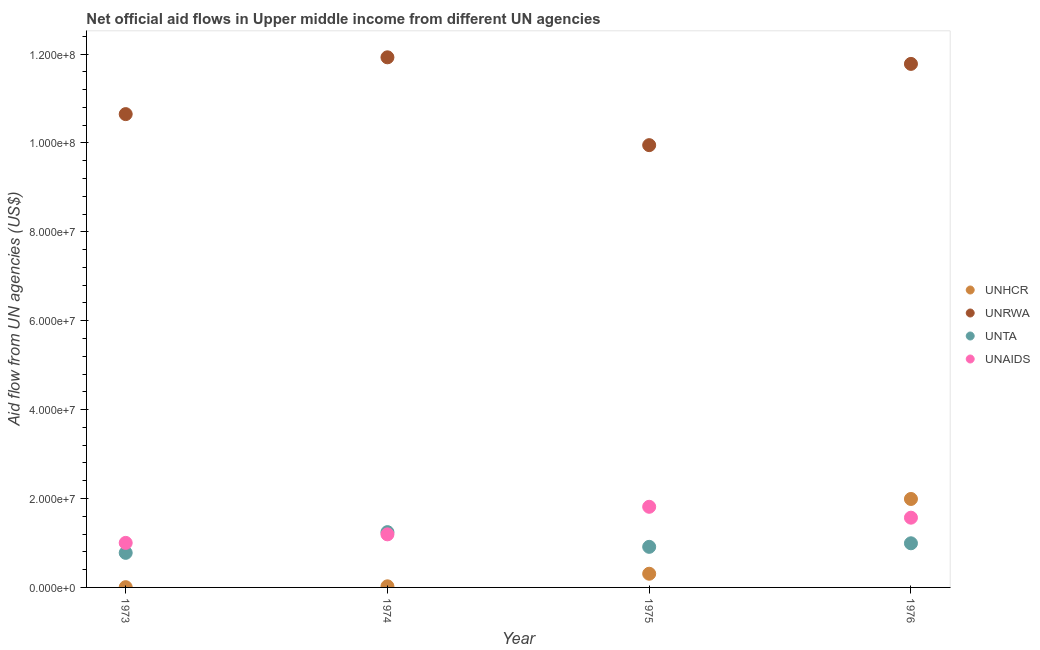Is the number of dotlines equal to the number of legend labels?
Provide a short and direct response. Yes. What is the amount of aid given by unaids in 1973?
Provide a short and direct response. 1.00e+07. Across all years, what is the maximum amount of aid given by unta?
Offer a very short reply. 1.24e+07. Across all years, what is the minimum amount of aid given by unaids?
Provide a succinct answer. 1.00e+07. In which year was the amount of aid given by unrwa maximum?
Ensure brevity in your answer.  1974. What is the total amount of aid given by unaids in the graph?
Your answer should be very brief. 5.58e+07. What is the difference between the amount of aid given by unta in 1975 and that in 1976?
Ensure brevity in your answer.  -8.00e+05. What is the difference between the amount of aid given by unrwa in 1976 and the amount of aid given by unta in 1973?
Offer a terse response. 1.10e+08. What is the average amount of aid given by unhcr per year?
Ensure brevity in your answer.  5.82e+06. In the year 1974, what is the difference between the amount of aid given by unrwa and amount of aid given by unaids?
Provide a short and direct response. 1.07e+08. What is the ratio of the amount of aid given by unaids in 1975 to that in 1976?
Ensure brevity in your answer.  1.16. Is the difference between the amount of aid given by unhcr in 1973 and 1974 greater than the difference between the amount of aid given by unaids in 1973 and 1974?
Offer a very short reply. Yes. What is the difference between the highest and the second highest amount of aid given by unrwa?
Provide a succinct answer. 1.48e+06. What is the difference between the highest and the lowest amount of aid given by unta?
Offer a terse response. 4.66e+06. In how many years, is the amount of aid given by unaids greater than the average amount of aid given by unaids taken over all years?
Your response must be concise. 2. Is the sum of the amount of aid given by unrwa in 1974 and 1976 greater than the maximum amount of aid given by unaids across all years?
Your response must be concise. Yes. Is it the case that in every year, the sum of the amount of aid given by unhcr and amount of aid given by unrwa is greater than the amount of aid given by unta?
Your response must be concise. Yes. Is the amount of aid given by unaids strictly greater than the amount of aid given by unhcr over the years?
Offer a terse response. No. Is the amount of aid given by unrwa strictly less than the amount of aid given by unta over the years?
Make the answer very short. No. How many years are there in the graph?
Provide a short and direct response. 4. Are the values on the major ticks of Y-axis written in scientific E-notation?
Make the answer very short. Yes. Does the graph contain any zero values?
Provide a succinct answer. No. Does the graph contain grids?
Provide a succinct answer. No. Where does the legend appear in the graph?
Offer a very short reply. Center right. How are the legend labels stacked?
Keep it short and to the point. Vertical. What is the title of the graph?
Provide a succinct answer. Net official aid flows in Upper middle income from different UN agencies. What is the label or title of the X-axis?
Keep it short and to the point. Year. What is the label or title of the Y-axis?
Your answer should be very brief. Aid flow from UN agencies (US$). What is the Aid flow from UN agencies (US$) of UNHCR in 1973?
Make the answer very short. 6.00e+04. What is the Aid flow from UN agencies (US$) in UNRWA in 1973?
Your answer should be very brief. 1.06e+08. What is the Aid flow from UN agencies (US$) in UNTA in 1973?
Your answer should be compact. 7.78e+06. What is the Aid flow from UN agencies (US$) of UNAIDS in 1973?
Provide a short and direct response. 1.00e+07. What is the Aid flow from UN agencies (US$) in UNHCR in 1974?
Give a very brief answer. 2.50e+05. What is the Aid flow from UN agencies (US$) of UNRWA in 1974?
Provide a succinct answer. 1.19e+08. What is the Aid flow from UN agencies (US$) in UNTA in 1974?
Give a very brief answer. 1.24e+07. What is the Aid flow from UN agencies (US$) of UNAIDS in 1974?
Provide a short and direct response. 1.19e+07. What is the Aid flow from UN agencies (US$) of UNHCR in 1975?
Make the answer very short. 3.08e+06. What is the Aid flow from UN agencies (US$) in UNRWA in 1975?
Provide a succinct answer. 9.95e+07. What is the Aid flow from UN agencies (US$) of UNTA in 1975?
Offer a terse response. 9.13e+06. What is the Aid flow from UN agencies (US$) of UNAIDS in 1975?
Ensure brevity in your answer.  1.81e+07. What is the Aid flow from UN agencies (US$) of UNHCR in 1976?
Your response must be concise. 1.99e+07. What is the Aid flow from UN agencies (US$) in UNRWA in 1976?
Your response must be concise. 1.18e+08. What is the Aid flow from UN agencies (US$) in UNTA in 1976?
Make the answer very short. 9.93e+06. What is the Aid flow from UN agencies (US$) in UNAIDS in 1976?
Make the answer very short. 1.57e+07. Across all years, what is the maximum Aid flow from UN agencies (US$) in UNHCR?
Provide a succinct answer. 1.99e+07. Across all years, what is the maximum Aid flow from UN agencies (US$) of UNRWA?
Keep it short and to the point. 1.19e+08. Across all years, what is the maximum Aid flow from UN agencies (US$) of UNTA?
Give a very brief answer. 1.24e+07. Across all years, what is the maximum Aid flow from UN agencies (US$) in UNAIDS?
Your answer should be very brief. 1.81e+07. Across all years, what is the minimum Aid flow from UN agencies (US$) in UNHCR?
Your answer should be compact. 6.00e+04. Across all years, what is the minimum Aid flow from UN agencies (US$) of UNRWA?
Ensure brevity in your answer.  9.95e+07. Across all years, what is the minimum Aid flow from UN agencies (US$) in UNTA?
Offer a very short reply. 7.78e+06. Across all years, what is the minimum Aid flow from UN agencies (US$) of UNAIDS?
Your response must be concise. 1.00e+07. What is the total Aid flow from UN agencies (US$) in UNHCR in the graph?
Offer a terse response. 2.33e+07. What is the total Aid flow from UN agencies (US$) in UNRWA in the graph?
Offer a very short reply. 4.43e+08. What is the total Aid flow from UN agencies (US$) of UNTA in the graph?
Offer a very short reply. 3.93e+07. What is the total Aid flow from UN agencies (US$) in UNAIDS in the graph?
Keep it short and to the point. 5.58e+07. What is the difference between the Aid flow from UN agencies (US$) of UNHCR in 1973 and that in 1974?
Keep it short and to the point. -1.90e+05. What is the difference between the Aid flow from UN agencies (US$) of UNRWA in 1973 and that in 1974?
Keep it short and to the point. -1.28e+07. What is the difference between the Aid flow from UN agencies (US$) in UNTA in 1973 and that in 1974?
Your answer should be compact. -4.66e+06. What is the difference between the Aid flow from UN agencies (US$) of UNAIDS in 1973 and that in 1974?
Your answer should be very brief. -1.92e+06. What is the difference between the Aid flow from UN agencies (US$) in UNHCR in 1973 and that in 1975?
Your response must be concise. -3.02e+06. What is the difference between the Aid flow from UN agencies (US$) of UNRWA in 1973 and that in 1975?
Offer a terse response. 6.98e+06. What is the difference between the Aid flow from UN agencies (US$) of UNTA in 1973 and that in 1975?
Your response must be concise. -1.35e+06. What is the difference between the Aid flow from UN agencies (US$) of UNAIDS in 1973 and that in 1975?
Offer a terse response. -8.12e+06. What is the difference between the Aid flow from UN agencies (US$) of UNHCR in 1973 and that in 1976?
Give a very brief answer. -1.98e+07. What is the difference between the Aid flow from UN agencies (US$) in UNRWA in 1973 and that in 1976?
Your answer should be very brief. -1.13e+07. What is the difference between the Aid flow from UN agencies (US$) in UNTA in 1973 and that in 1976?
Ensure brevity in your answer.  -2.15e+06. What is the difference between the Aid flow from UN agencies (US$) in UNAIDS in 1973 and that in 1976?
Keep it short and to the point. -5.67e+06. What is the difference between the Aid flow from UN agencies (US$) in UNHCR in 1974 and that in 1975?
Offer a very short reply. -2.83e+06. What is the difference between the Aid flow from UN agencies (US$) in UNRWA in 1974 and that in 1975?
Make the answer very short. 1.98e+07. What is the difference between the Aid flow from UN agencies (US$) of UNTA in 1974 and that in 1975?
Give a very brief answer. 3.31e+06. What is the difference between the Aid flow from UN agencies (US$) of UNAIDS in 1974 and that in 1975?
Offer a very short reply. -6.20e+06. What is the difference between the Aid flow from UN agencies (US$) of UNHCR in 1974 and that in 1976?
Your answer should be very brief. -1.96e+07. What is the difference between the Aid flow from UN agencies (US$) of UNRWA in 1974 and that in 1976?
Give a very brief answer. 1.48e+06. What is the difference between the Aid flow from UN agencies (US$) in UNTA in 1974 and that in 1976?
Give a very brief answer. 2.51e+06. What is the difference between the Aid flow from UN agencies (US$) in UNAIDS in 1974 and that in 1976?
Offer a very short reply. -3.75e+06. What is the difference between the Aid flow from UN agencies (US$) of UNHCR in 1975 and that in 1976?
Give a very brief answer. -1.68e+07. What is the difference between the Aid flow from UN agencies (US$) in UNRWA in 1975 and that in 1976?
Your response must be concise. -1.83e+07. What is the difference between the Aid flow from UN agencies (US$) of UNTA in 1975 and that in 1976?
Your answer should be compact. -8.00e+05. What is the difference between the Aid flow from UN agencies (US$) in UNAIDS in 1975 and that in 1976?
Provide a succinct answer. 2.45e+06. What is the difference between the Aid flow from UN agencies (US$) in UNHCR in 1973 and the Aid flow from UN agencies (US$) in UNRWA in 1974?
Your answer should be very brief. -1.19e+08. What is the difference between the Aid flow from UN agencies (US$) of UNHCR in 1973 and the Aid flow from UN agencies (US$) of UNTA in 1974?
Ensure brevity in your answer.  -1.24e+07. What is the difference between the Aid flow from UN agencies (US$) of UNHCR in 1973 and the Aid flow from UN agencies (US$) of UNAIDS in 1974?
Give a very brief answer. -1.19e+07. What is the difference between the Aid flow from UN agencies (US$) of UNRWA in 1973 and the Aid flow from UN agencies (US$) of UNTA in 1974?
Keep it short and to the point. 9.40e+07. What is the difference between the Aid flow from UN agencies (US$) in UNRWA in 1973 and the Aid flow from UN agencies (US$) in UNAIDS in 1974?
Your response must be concise. 9.45e+07. What is the difference between the Aid flow from UN agencies (US$) in UNTA in 1973 and the Aid flow from UN agencies (US$) in UNAIDS in 1974?
Your answer should be compact. -4.16e+06. What is the difference between the Aid flow from UN agencies (US$) of UNHCR in 1973 and the Aid flow from UN agencies (US$) of UNRWA in 1975?
Give a very brief answer. -9.94e+07. What is the difference between the Aid flow from UN agencies (US$) of UNHCR in 1973 and the Aid flow from UN agencies (US$) of UNTA in 1975?
Provide a short and direct response. -9.07e+06. What is the difference between the Aid flow from UN agencies (US$) of UNHCR in 1973 and the Aid flow from UN agencies (US$) of UNAIDS in 1975?
Make the answer very short. -1.81e+07. What is the difference between the Aid flow from UN agencies (US$) in UNRWA in 1973 and the Aid flow from UN agencies (US$) in UNTA in 1975?
Provide a succinct answer. 9.74e+07. What is the difference between the Aid flow from UN agencies (US$) of UNRWA in 1973 and the Aid flow from UN agencies (US$) of UNAIDS in 1975?
Your answer should be compact. 8.83e+07. What is the difference between the Aid flow from UN agencies (US$) in UNTA in 1973 and the Aid flow from UN agencies (US$) in UNAIDS in 1975?
Offer a terse response. -1.04e+07. What is the difference between the Aid flow from UN agencies (US$) in UNHCR in 1973 and the Aid flow from UN agencies (US$) in UNRWA in 1976?
Your answer should be very brief. -1.18e+08. What is the difference between the Aid flow from UN agencies (US$) of UNHCR in 1973 and the Aid flow from UN agencies (US$) of UNTA in 1976?
Your answer should be very brief. -9.87e+06. What is the difference between the Aid flow from UN agencies (US$) of UNHCR in 1973 and the Aid flow from UN agencies (US$) of UNAIDS in 1976?
Provide a short and direct response. -1.56e+07. What is the difference between the Aid flow from UN agencies (US$) in UNRWA in 1973 and the Aid flow from UN agencies (US$) in UNTA in 1976?
Your answer should be compact. 9.66e+07. What is the difference between the Aid flow from UN agencies (US$) in UNRWA in 1973 and the Aid flow from UN agencies (US$) in UNAIDS in 1976?
Provide a succinct answer. 9.08e+07. What is the difference between the Aid flow from UN agencies (US$) in UNTA in 1973 and the Aid flow from UN agencies (US$) in UNAIDS in 1976?
Keep it short and to the point. -7.91e+06. What is the difference between the Aid flow from UN agencies (US$) in UNHCR in 1974 and the Aid flow from UN agencies (US$) in UNRWA in 1975?
Make the answer very short. -9.92e+07. What is the difference between the Aid flow from UN agencies (US$) in UNHCR in 1974 and the Aid flow from UN agencies (US$) in UNTA in 1975?
Your answer should be compact. -8.88e+06. What is the difference between the Aid flow from UN agencies (US$) in UNHCR in 1974 and the Aid flow from UN agencies (US$) in UNAIDS in 1975?
Ensure brevity in your answer.  -1.79e+07. What is the difference between the Aid flow from UN agencies (US$) of UNRWA in 1974 and the Aid flow from UN agencies (US$) of UNTA in 1975?
Your answer should be very brief. 1.10e+08. What is the difference between the Aid flow from UN agencies (US$) of UNRWA in 1974 and the Aid flow from UN agencies (US$) of UNAIDS in 1975?
Offer a terse response. 1.01e+08. What is the difference between the Aid flow from UN agencies (US$) in UNTA in 1974 and the Aid flow from UN agencies (US$) in UNAIDS in 1975?
Provide a short and direct response. -5.70e+06. What is the difference between the Aid flow from UN agencies (US$) in UNHCR in 1974 and the Aid flow from UN agencies (US$) in UNRWA in 1976?
Your response must be concise. -1.18e+08. What is the difference between the Aid flow from UN agencies (US$) in UNHCR in 1974 and the Aid flow from UN agencies (US$) in UNTA in 1976?
Offer a very short reply. -9.68e+06. What is the difference between the Aid flow from UN agencies (US$) of UNHCR in 1974 and the Aid flow from UN agencies (US$) of UNAIDS in 1976?
Offer a terse response. -1.54e+07. What is the difference between the Aid flow from UN agencies (US$) in UNRWA in 1974 and the Aid flow from UN agencies (US$) in UNTA in 1976?
Keep it short and to the point. 1.09e+08. What is the difference between the Aid flow from UN agencies (US$) of UNRWA in 1974 and the Aid flow from UN agencies (US$) of UNAIDS in 1976?
Make the answer very short. 1.04e+08. What is the difference between the Aid flow from UN agencies (US$) of UNTA in 1974 and the Aid flow from UN agencies (US$) of UNAIDS in 1976?
Make the answer very short. -3.25e+06. What is the difference between the Aid flow from UN agencies (US$) of UNHCR in 1975 and the Aid flow from UN agencies (US$) of UNRWA in 1976?
Your answer should be very brief. -1.15e+08. What is the difference between the Aid flow from UN agencies (US$) of UNHCR in 1975 and the Aid flow from UN agencies (US$) of UNTA in 1976?
Provide a short and direct response. -6.85e+06. What is the difference between the Aid flow from UN agencies (US$) of UNHCR in 1975 and the Aid flow from UN agencies (US$) of UNAIDS in 1976?
Your response must be concise. -1.26e+07. What is the difference between the Aid flow from UN agencies (US$) in UNRWA in 1975 and the Aid flow from UN agencies (US$) in UNTA in 1976?
Provide a succinct answer. 8.96e+07. What is the difference between the Aid flow from UN agencies (US$) of UNRWA in 1975 and the Aid flow from UN agencies (US$) of UNAIDS in 1976?
Give a very brief answer. 8.38e+07. What is the difference between the Aid flow from UN agencies (US$) in UNTA in 1975 and the Aid flow from UN agencies (US$) in UNAIDS in 1976?
Make the answer very short. -6.56e+06. What is the average Aid flow from UN agencies (US$) of UNHCR per year?
Provide a succinct answer. 5.82e+06. What is the average Aid flow from UN agencies (US$) in UNRWA per year?
Your answer should be very brief. 1.11e+08. What is the average Aid flow from UN agencies (US$) of UNTA per year?
Ensure brevity in your answer.  9.82e+06. What is the average Aid flow from UN agencies (US$) in UNAIDS per year?
Provide a short and direct response. 1.39e+07. In the year 1973, what is the difference between the Aid flow from UN agencies (US$) in UNHCR and Aid flow from UN agencies (US$) in UNRWA?
Make the answer very short. -1.06e+08. In the year 1973, what is the difference between the Aid flow from UN agencies (US$) of UNHCR and Aid flow from UN agencies (US$) of UNTA?
Your answer should be compact. -7.72e+06. In the year 1973, what is the difference between the Aid flow from UN agencies (US$) of UNHCR and Aid flow from UN agencies (US$) of UNAIDS?
Your answer should be compact. -9.96e+06. In the year 1973, what is the difference between the Aid flow from UN agencies (US$) in UNRWA and Aid flow from UN agencies (US$) in UNTA?
Keep it short and to the point. 9.87e+07. In the year 1973, what is the difference between the Aid flow from UN agencies (US$) of UNRWA and Aid flow from UN agencies (US$) of UNAIDS?
Your answer should be very brief. 9.65e+07. In the year 1973, what is the difference between the Aid flow from UN agencies (US$) of UNTA and Aid flow from UN agencies (US$) of UNAIDS?
Your answer should be very brief. -2.24e+06. In the year 1974, what is the difference between the Aid flow from UN agencies (US$) of UNHCR and Aid flow from UN agencies (US$) of UNRWA?
Ensure brevity in your answer.  -1.19e+08. In the year 1974, what is the difference between the Aid flow from UN agencies (US$) in UNHCR and Aid flow from UN agencies (US$) in UNTA?
Provide a succinct answer. -1.22e+07. In the year 1974, what is the difference between the Aid flow from UN agencies (US$) of UNHCR and Aid flow from UN agencies (US$) of UNAIDS?
Your answer should be compact. -1.17e+07. In the year 1974, what is the difference between the Aid flow from UN agencies (US$) of UNRWA and Aid flow from UN agencies (US$) of UNTA?
Offer a very short reply. 1.07e+08. In the year 1974, what is the difference between the Aid flow from UN agencies (US$) of UNRWA and Aid flow from UN agencies (US$) of UNAIDS?
Ensure brevity in your answer.  1.07e+08. In the year 1974, what is the difference between the Aid flow from UN agencies (US$) in UNTA and Aid flow from UN agencies (US$) in UNAIDS?
Provide a succinct answer. 5.00e+05. In the year 1975, what is the difference between the Aid flow from UN agencies (US$) of UNHCR and Aid flow from UN agencies (US$) of UNRWA?
Your answer should be very brief. -9.64e+07. In the year 1975, what is the difference between the Aid flow from UN agencies (US$) in UNHCR and Aid flow from UN agencies (US$) in UNTA?
Give a very brief answer. -6.05e+06. In the year 1975, what is the difference between the Aid flow from UN agencies (US$) in UNHCR and Aid flow from UN agencies (US$) in UNAIDS?
Make the answer very short. -1.51e+07. In the year 1975, what is the difference between the Aid flow from UN agencies (US$) of UNRWA and Aid flow from UN agencies (US$) of UNTA?
Make the answer very short. 9.04e+07. In the year 1975, what is the difference between the Aid flow from UN agencies (US$) in UNRWA and Aid flow from UN agencies (US$) in UNAIDS?
Your answer should be compact. 8.14e+07. In the year 1975, what is the difference between the Aid flow from UN agencies (US$) of UNTA and Aid flow from UN agencies (US$) of UNAIDS?
Keep it short and to the point. -9.01e+06. In the year 1976, what is the difference between the Aid flow from UN agencies (US$) of UNHCR and Aid flow from UN agencies (US$) of UNRWA?
Give a very brief answer. -9.79e+07. In the year 1976, what is the difference between the Aid flow from UN agencies (US$) of UNHCR and Aid flow from UN agencies (US$) of UNTA?
Make the answer very short. 9.97e+06. In the year 1976, what is the difference between the Aid flow from UN agencies (US$) of UNHCR and Aid flow from UN agencies (US$) of UNAIDS?
Your answer should be very brief. 4.21e+06. In the year 1976, what is the difference between the Aid flow from UN agencies (US$) of UNRWA and Aid flow from UN agencies (US$) of UNTA?
Your response must be concise. 1.08e+08. In the year 1976, what is the difference between the Aid flow from UN agencies (US$) of UNRWA and Aid flow from UN agencies (US$) of UNAIDS?
Your response must be concise. 1.02e+08. In the year 1976, what is the difference between the Aid flow from UN agencies (US$) of UNTA and Aid flow from UN agencies (US$) of UNAIDS?
Make the answer very short. -5.76e+06. What is the ratio of the Aid flow from UN agencies (US$) of UNHCR in 1973 to that in 1974?
Ensure brevity in your answer.  0.24. What is the ratio of the Aid flow from UN agencies (US$) in UNRWA in 1973 to that in 1974?
Make the answer very short. 0.89. What is the ratio of the Aid flow from UN agencies (US$) in UNTA in 1973 to that in 1974?
Your answer should be very brief. 0.63. What is the ratio of the Aid flow from UN agencies (US$) of UNAIDS in 1973 to that in 1974?
Offer a terse response. 0.84. What is the ratio of the Aid flow from UN agencies (US$) in UNHCR in 1973 to that in 1975?
Provide a succinct answer. 0.02. What is the ratio of the Aid flow from UN agencies (US$) of UNRWA in 1973 to that in 1975?
Your answer should be compact. 1.07. What is the ratio of the Aid flow from UN agencies (US$) of UNTA in 1973 to that in 1975?
Your answer should be compact. 0.85. What is the ratio of the Aid flow from UN agencies (US$) in UNAIDS in 1973 to that in 1975?
Provide a succinct answer. 0.55. What is the ratio of the Aid flow from UN agencies (US$) in UNHCR in 1973 to that in 1976?
Ensure brevity in your answer.  0. What is the ratio of the Aid flow from UN agencies (US$) in UNRWA in 1973 to that in 1976?
Make the answer very short. 0.9. What is the ratio of the Aid flow from UN agencies (US$) in UNTA in 1973 to that in 1976?
Offer a terse response. 0.78. What is the ratio of the Aid flow from UN agencies (US$) in UNAIDS in 1973 to that in 1976?
Keep it short and to the point. 0.64. What is the ratio of the Aid flow from UN agencies (US$) of UNHCR in 1974 to that in 1975?
Your answer should be compact. 0.08. What is the ratio of the Aid flow from UN agencies (US$) in UNRWA in 1974 to that in 1975?
Your answer should be compact. 1.2. What is the ratio of the Aid flow from UN agencies (US$) in UNTA in 1974 to that in 1975?
Provide a short and direct response. 1.36. What is the ratio of the Aid flow from UN agencies (US$) in UNAIDS in 1974 to that in 1975?
Give a very brief answer. 0.66. What is the ratio of the Aid flow from UN agencies (US$) in UNHCR in 1974 to that in 1976?
Provide a succinct answer. 0.01. What is the ratio of the Aid flow from UN agencies (US$) in UNRWA in 1974 to that in 1976?
Offer a very short reply. 1.01. What is the ratio of the Aid flow from UN agencies (US$) of UNTA in 1974 to that in 1976?
Your answer should be compact. 1.25. What is the ratio of the Aid flow from UN agencies (US$) of UNAIDS in 1974 to that in 1976?
Offer a very short reply. 0.76. What is the ratio of the Aid flow from UN agencies (US$) of UNHCR in 1975 to that in 1976?
Offer a terse response. 0.15. What is the ratio of the Aid flow from UN agencies (US$) in UNRWA in 1975 to that in 1976?
Your answer should be very brief. 0.84. What is the ratio of the Aid flow from UN agencies (US$) of UNTA in 1975 to that in 1976?
Your answer should be compact. 0.92. What is the ratio of the Aid flow from UN agencies (US$) in UNAIDS in 1975 to that in 1976?
Give a very brief answer. 1.16. What is the difference between the highest and the second highest Aid flow from UN agencies (US$) of UNHCR?
Ensure brevity in your answer.  1.68e+07. What is the difference between the highest and the second highest Aid flow from UN agencies (US$) of UNRWA?
Your answer should be very brief. 1.48e+06. What is the difference between the highest and the second highest Aid flow from UN agencies (US$) in UNTA?
Offer a very short reply. 2.51e+06. What is the difference between the highest and the second highest Aid flow from UN agencies (US$) in UNAIDS?
Make the answer very short. 2.45e+06. What is the difference between the highest and the lowest Aid flow from UN agencies (US$) of UNHCR?
Your answer should be compact. 1.98e+07. What is the difference between the highest and the lowest Aid flow from UN agencies (US$) in UNRWA?
Give a very brief answer. 1.98e+07. What is the difference between the highest and the lowest Aid flow from UN agencies (US$) in UNTA?
Your answer should be compact. 4.66e+06. What is the difference between the highest and the lowest Aid flow from UN agencies (US$) in UNAIDS?
Keep it short and to the point. 8.12e+06. 